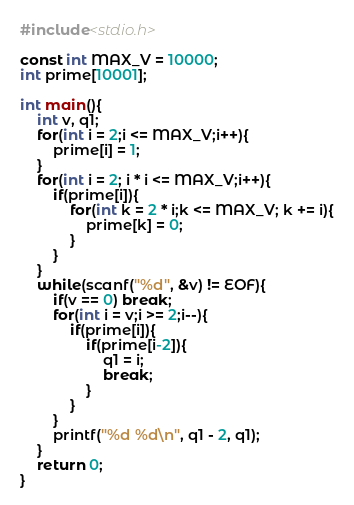<code> <loc_0><loc_0><loc_500><loc_500><_C_>#include<stdio.h>
 
const int MAX_V = 10000;
int prime[10001];
 
int main(){
    int v, q1;
    for(int i = 2;i <= MAX_V;i++){
        prime[i] = 1;
    }
    for(int i = 2; i * i <= MAX_V;i++){
        if(prime[i]){
            for(int k = 2 * i;k <= MAX_V; k += i){
                prime[k] = 0;
            }
        }
    }
    while(scanf("%d", &v) != EOF){
        if(v == 0) break;
        for(int i = v;i >= 2;i--){
            if(prime[i]){
                if(prime[i-2]){
                    q1 = i;
                    break;
                }
            }
        }
        printf("%d %d\n", q1 - 2, q1);
    }
    return 0;
}</code> 